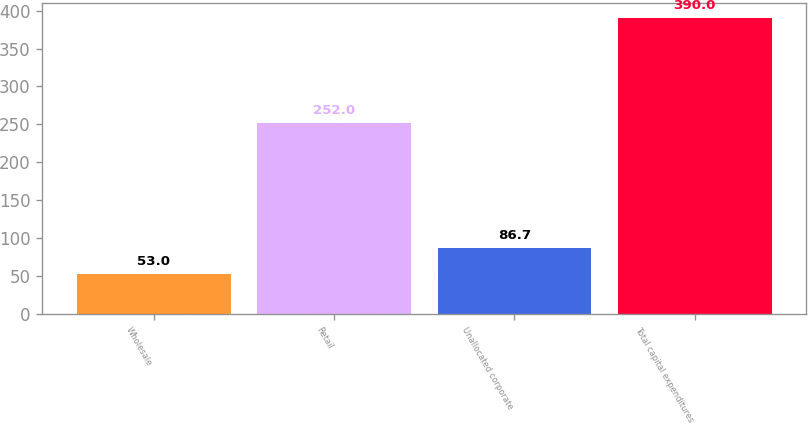Convert chart to OTSL. <chart><loc_0><loc_0><loc_500><loc_500><bar_chart><fcel>Wholesale<fcel>Retail<fcel>Unallocated corporate<fcel>Total capital expenditures<nl><fcel>53<fcel>252<fcel>86.7<fcel>390<nl></chart> 